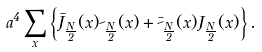Convert formula to latex. <formula><loc_0><loc_0><loc_500><loc_500>a ^ { 4 } \sum _ { x } \left \{ \bar { J } _ { \frac { N } { 2 } } ( x ) \psi _ { \frac { N } { 2 } } ( x ) + \bar { \psi } _ { \frac { N } { 2 } } ( x ) J _ { \frac { N } { 2 } } ( x ) \right \} .</formula> 